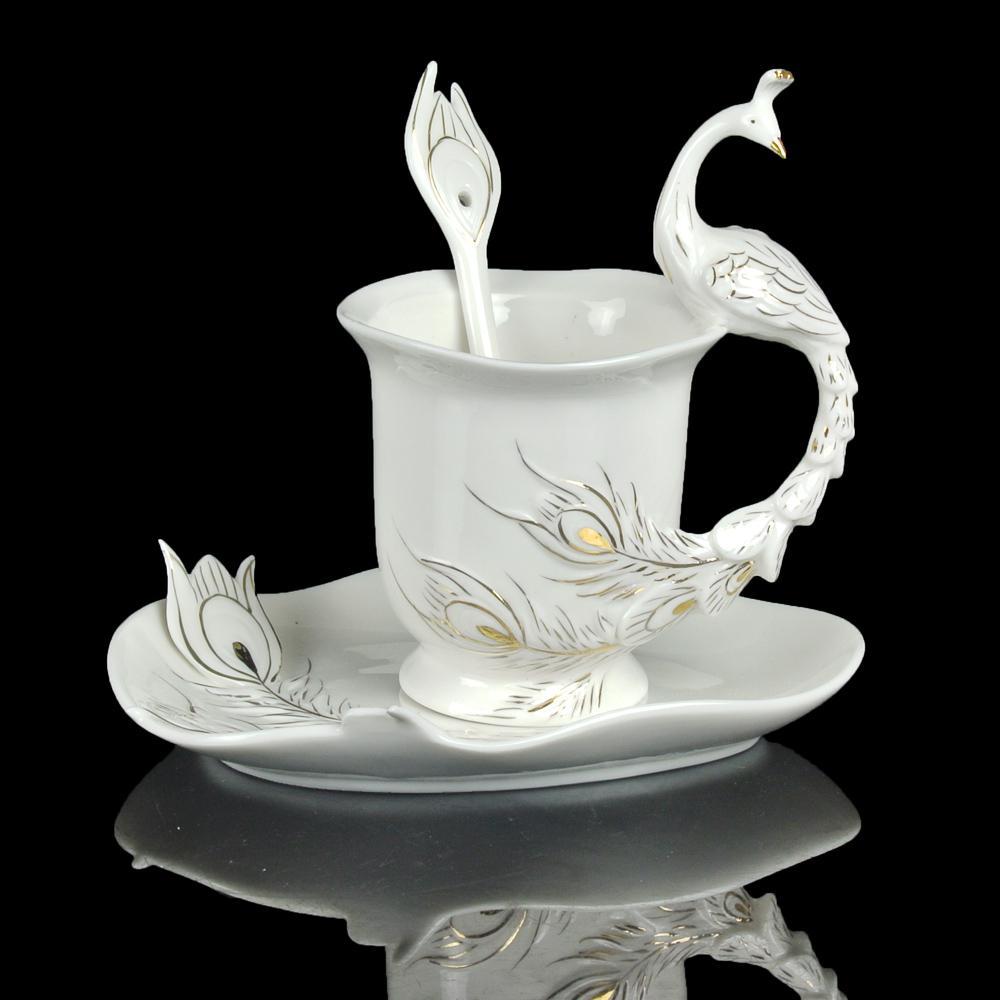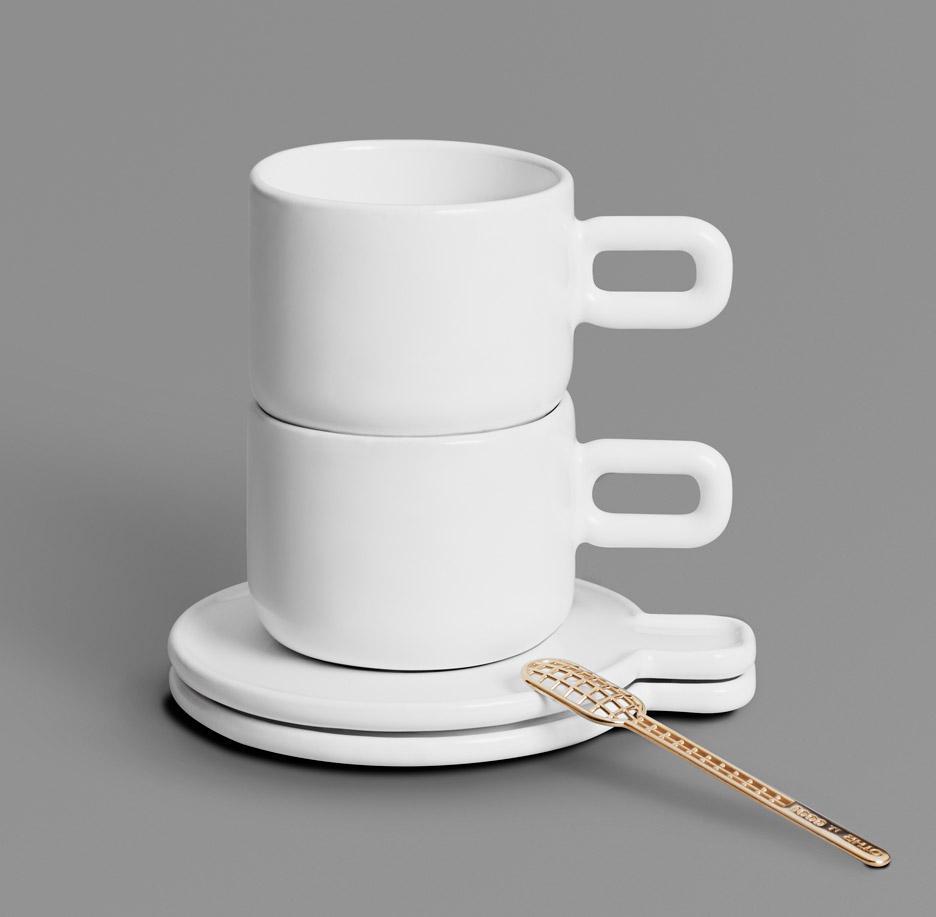The first image is the image on the left, the second image is the image on the right. For the images shown, is this caption "In each image there is a spoon laid next to the cup on the plate." true? Answer yes or no. No. The first image is the image on the left, the second image is the image on the right. Evaluate the accuracy of this statement regarding the images: "Both cups have a spoon sitting on their saucer.". Is it true? Answer yes or no. No. 